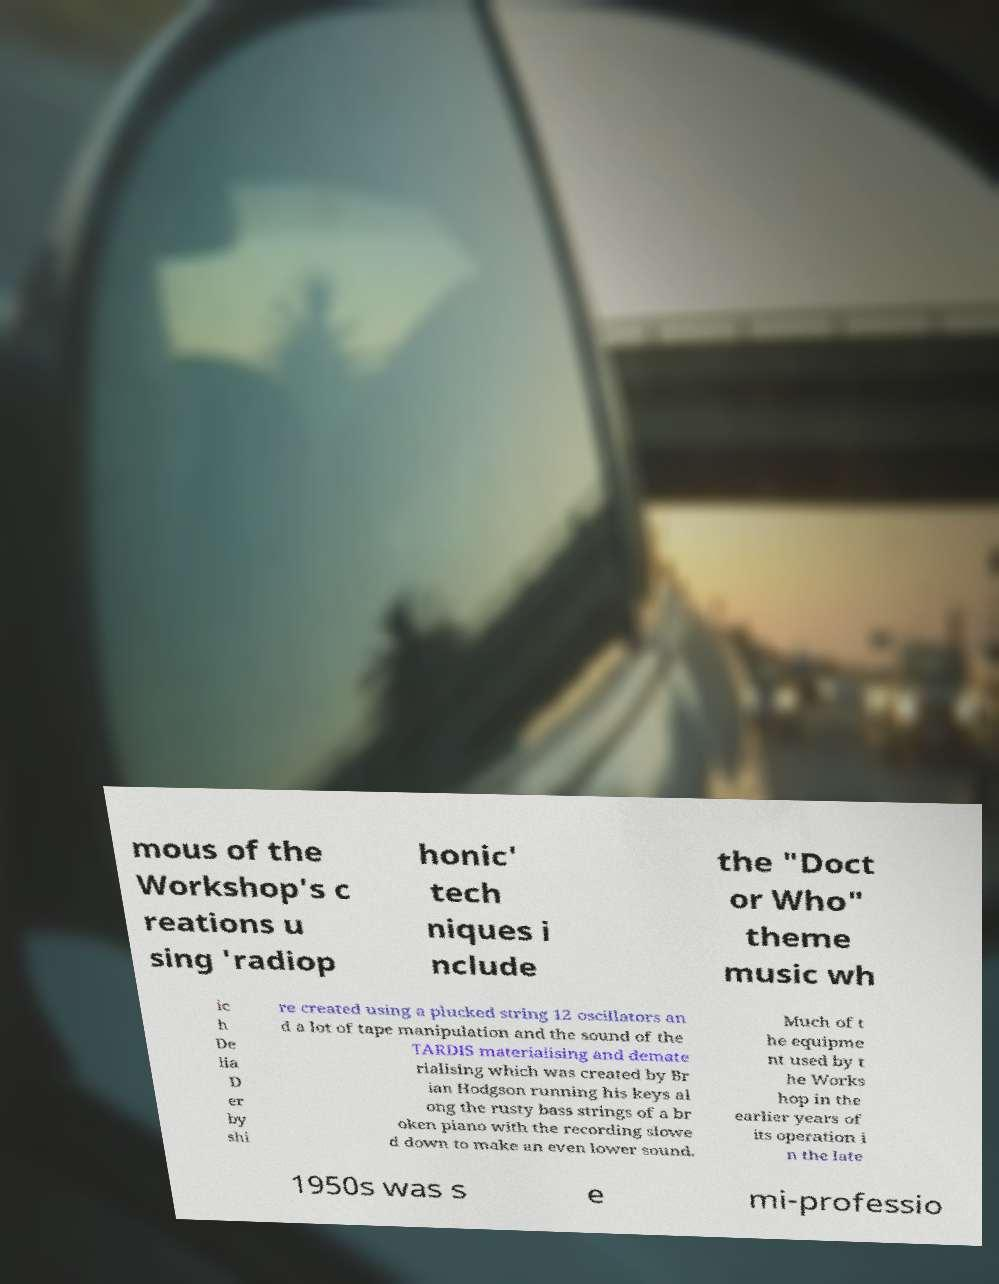Can you accurately transcribe the text from the provided image for me? mous of the Workshop's c reations u sing 'radiop honic' tech niques i nclude the "Doct or Who" theme music wh ic h De lia D er by shi re created using a plucked string 12 oscillators an d a lot of tape manipulation and the sound of the TARDIS materialising and demate rialising which was created by Br ian Hodgson running his keys al ong the rusty bass strings of a br oken piano with the recording slowe d down to make an even lower sound. Much of t he equipme nt used by t he Works hop in the earlier years of its operation i n the late 1950s was s e mi-professio 